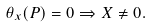Convert formula to latex. <formula><loc_0><loc_0><loc_500><loc_500>\theta _ { x } ( P ) = 0 \Rightarrow X \neq 0 .</formula> 